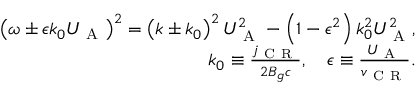Convert formula to latex. <formula><loc_0><loc_0><loc_500><loc_500>\begin{array} { r } { \left ( \omega \pm \epsilon k _ { 0 } U _ { A } \right ) ^ { 2 } = \left ( k \pm k _ { 0 } \right ) ^ { 2 } U _ { A } ^ { 2 } - \left ( 1 - \epsilon ^ { 2 } \right ) k _ { 0 } ^ { 2 } U _ { A } ^ { 2 } , } \\ { k _ { 0 } \equiv \frac { j _ { C R } } { 2 B _ { g } c } , \quad \epsilon \equiv \frac { U _ { A } } { v _ { C R } } . } \end{array}</formula> 